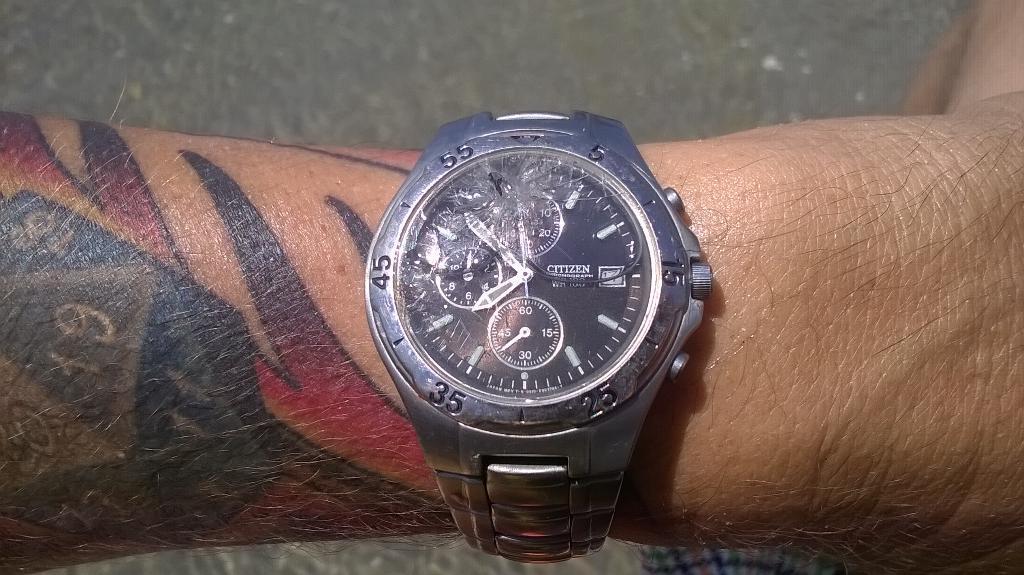Please provide a concise description of this image. In this picture we can see the tattoo, numbers and watch on the hand of a person. We can see a road. 